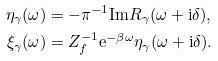Convert formula to latex. <formula><loc_0><loc_0><loc_500><loc_500>\eta _ { \gamma } ( \omega ) & = - \pi ^ { - 1 } \text {Im} R _ { \gamma } ( \omega + \text {i} \delta ) , \\ \xi _ { \gamma } ( \omega ) & = Z _ { f } ^ { - 1 } \text {e} ^ { - \beta \omega } \eta _ { \gamma } ( \omega + \text {i} \delta ) .</formula> 